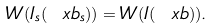Convert formula to latex. <formula><loc_0><loc_0><loc_500><loc_500>W ( I _ { s } ( \ x b _ { s } ) ) = W ( I ( \ x b ) ) .</formula> 